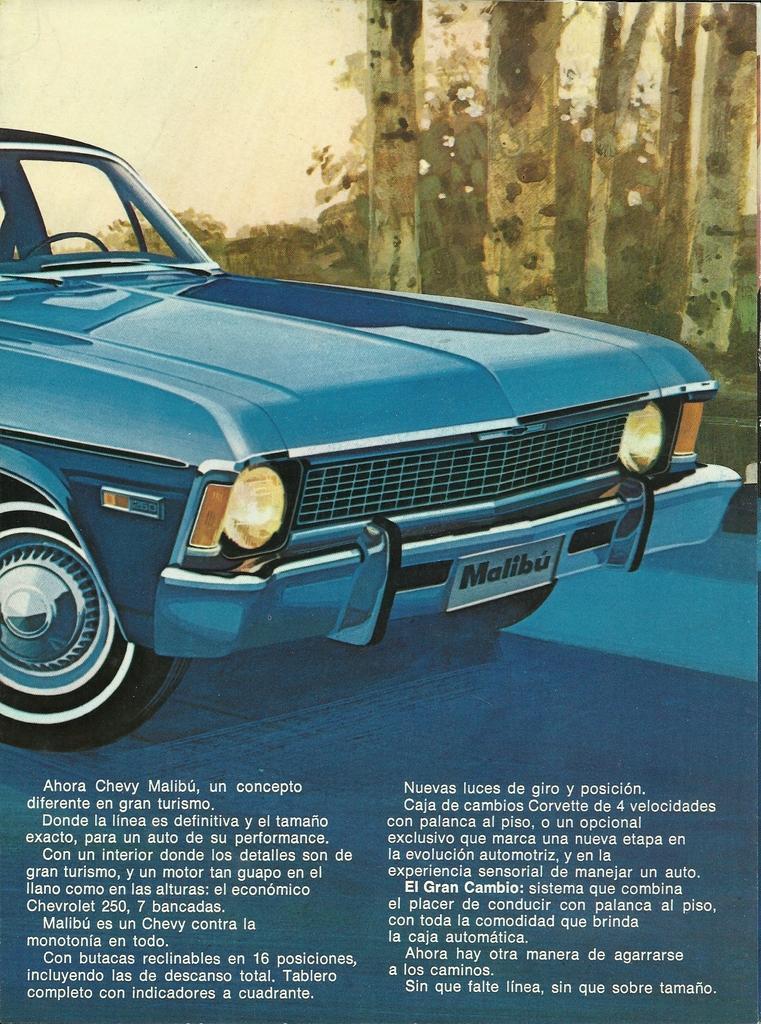In one or two sentences, can you explain what this image depicts? This image is a poster. In the center of the image there is a car. At the bottom of the image there is some text. 